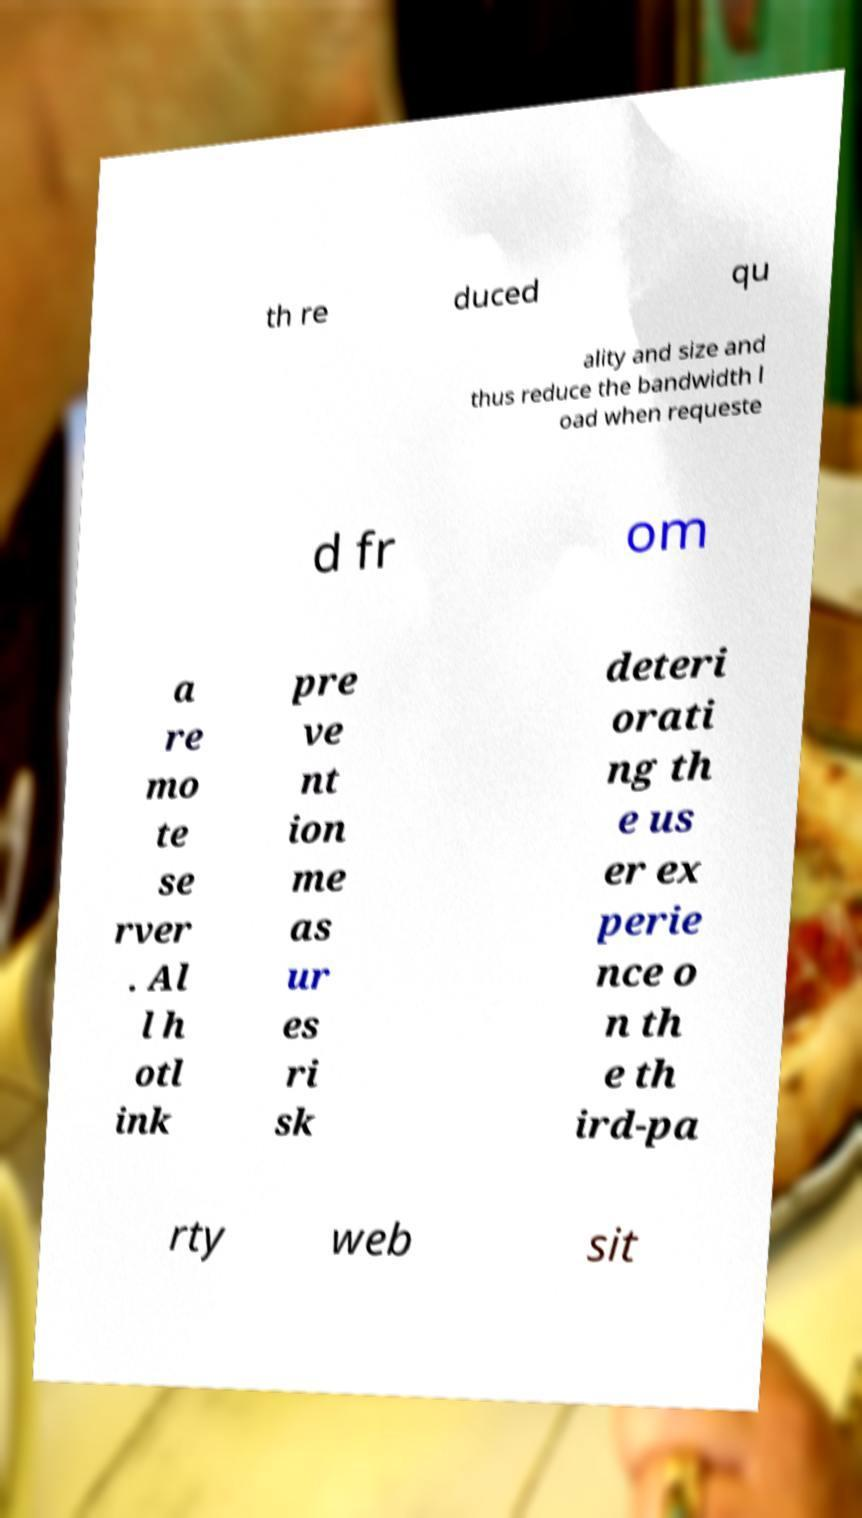Could you extract and type out the text from this image? th re duced qu ality and size and thus reduce the bandwidth l oad when requeste d fr om a re mo te se rver . Al l h otl ink pre ve nt ion me as ur es ri sk deteri orati ng th e us er ex perie nce o n th e th ird-pa rty web sit 